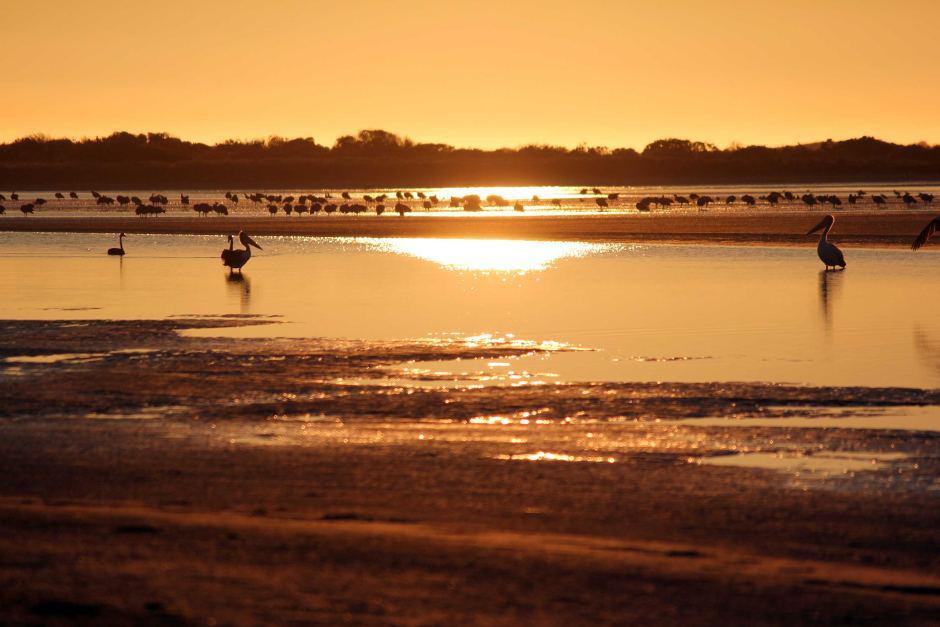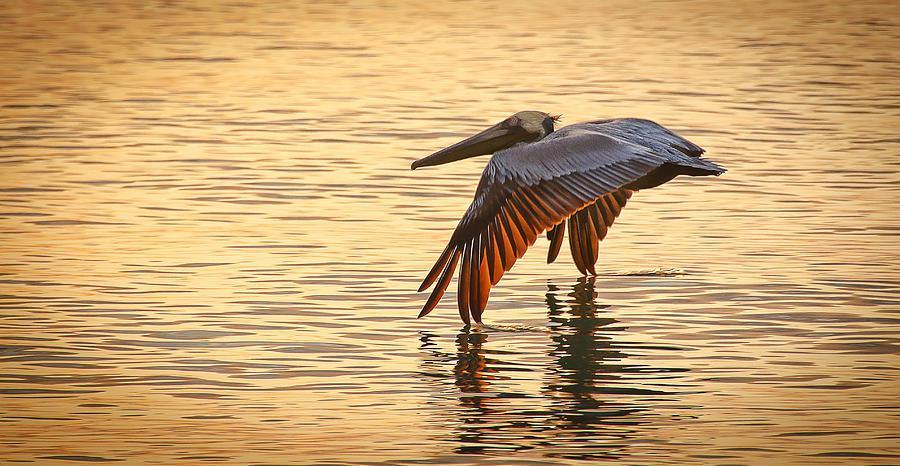The first image is the image on the left, the second image is the image on the right. Assess this claim about the two images: "A pelican perches on a pole in the image on the left.". Correct or not? Answer yes or no. No. The first image is the image on the left, the second image is the image on the right. Analyze the images presented: Is the assertion "An image shows a pelican perched on a tall post next to a shorter post, in front of a sky with no birds flying across it." valid? Answer yes or no. No. 